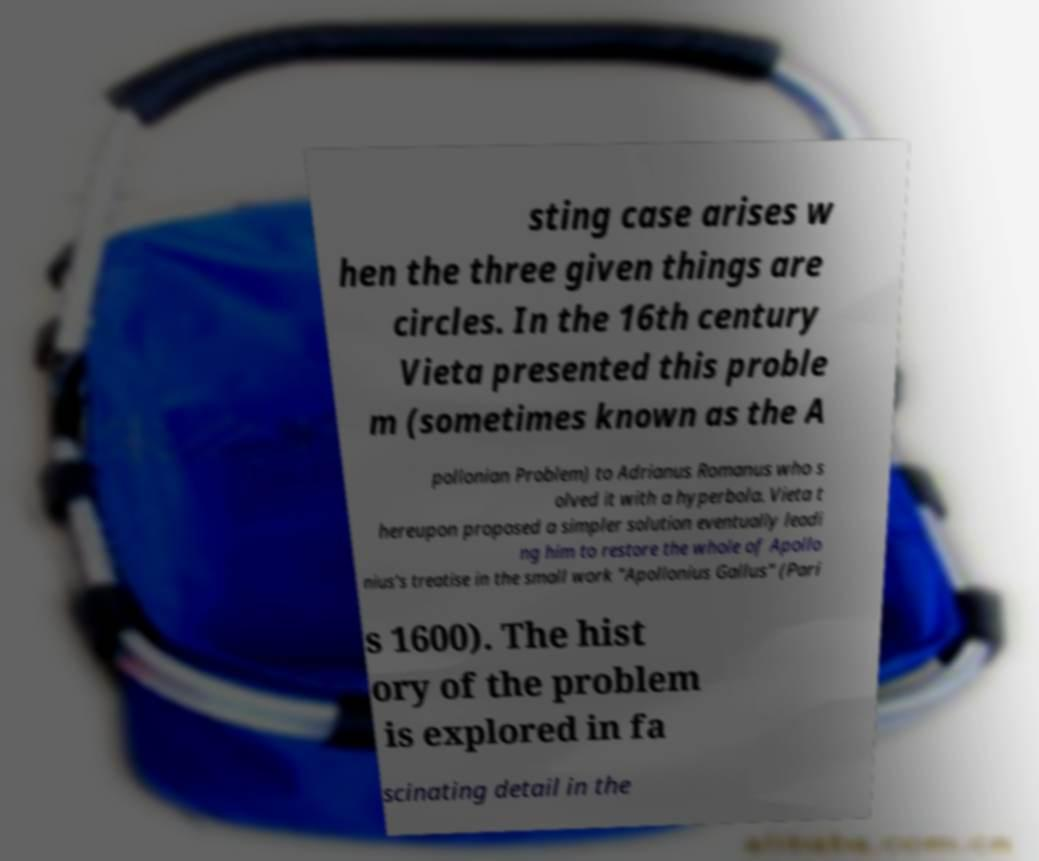Please read and relay the text visible in this image. What does it say? sting case arises w hen the three given things are circles. In the 16th century Vieta presented this proble m (sometimes known as the A pollonian Problem) to Adrianus Romanus who s olved it with a hyperbola. Vieta t hereupon proposed a simpler solution eventually leadi ng him to restore the whole of Apollo nius's treatise in the small work "Apollonius Gallus" (Pari s 1600). The hist ory of the problem is explored in fa scinating detail in the 